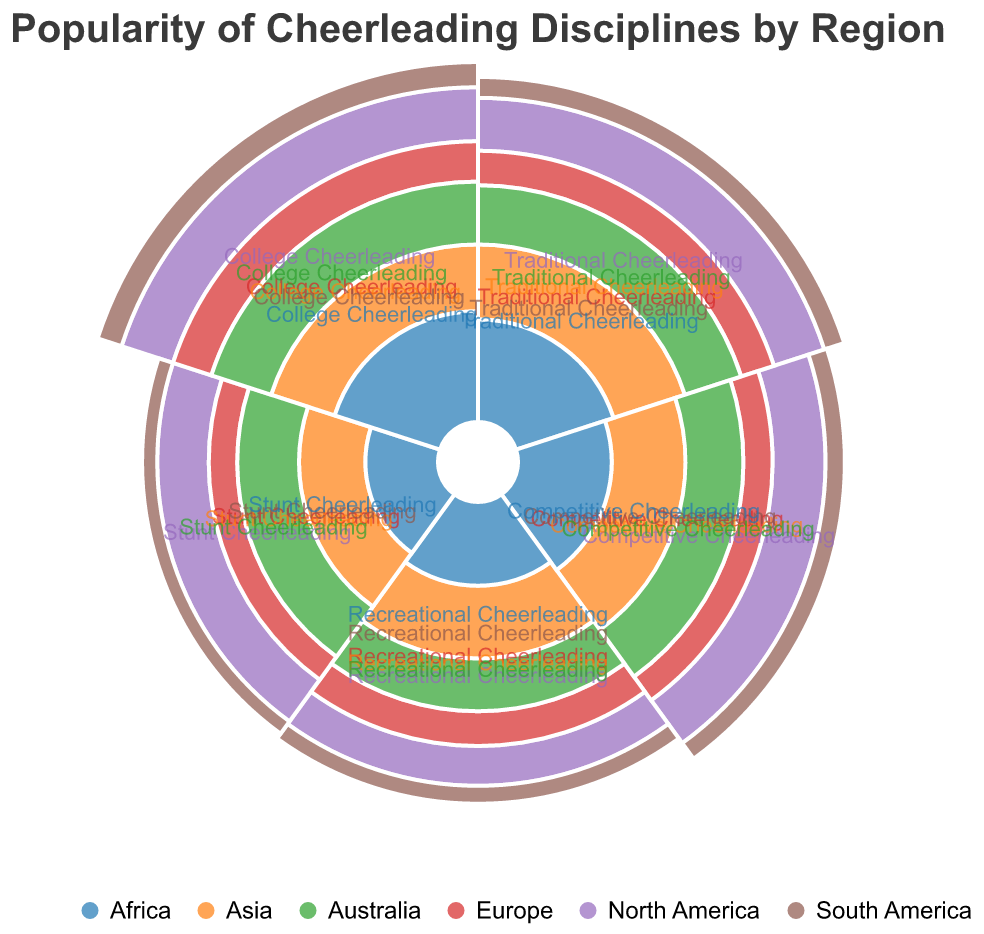What is the title of the figure? The title is usually located at the top of the figure. In this case, it indicates what the chart is about.
Answer: Popularity of Cheerleading Disciplines by Region Which region has the highest popularity in Traditional Cheerleading? By examining the lengths of the arcs corresponding to Traditional Cheerleading in each region, the longest arc will indicate the highest popularity.
Answer: North America Compare the popularity of Competitive Cheerleading in Europe and Africa. Which is more popular? Look at the arcs corresponding to Competitive Cheerleading in both Europe and Africa. The arc with a greater radius represents higher popularity.
Answer: Europe Which cheerleading discipline is least popular in South America? Analyze the arcs for each discipline in South America, and identify the arc with the smallest radius.
Answer: Stunt Cheerleading What region shows the lowest popularity in Stunt Cheerleading? Compare the lengths of the arcs for Stunt Cheerleading across all regions, and find the shortest one.
Answer: Africa Which region has the most balanced popularity across all cheerleading disciplines? A balanced distribution will have arcs of relatively similar lengths across disciplines.
Answer: Asia How does the popularity of College Cheerleading in Australia compare to North America? Compare the arcs for College Cheerleading for Australia and North America. The one with the greater radius is more popular.
Answer: North America What is the average popularity of cheerleading disciplines in Europe? Add the popularity scores for all five disciplines in Europe and divide by 5. (50 + 40 + 45 + 35 + 60) / 5 = 46
Answer: 46 In terms of total popularity, which region ranks second among all regions? Calculate the total popularity for each region by summing up the popularity scores for all disciplines, then compare. North America is first, and Australia is second with (70 + 65 + 55 + 60 + 75) = 325
Answer: Australia Is Competitive Cheerleading more popular in Asia or Australia? Compare the arcs for Competitive Cheerleading between Asia and Australia. The larger arc indicates higher popularity.
Answer: Australia 